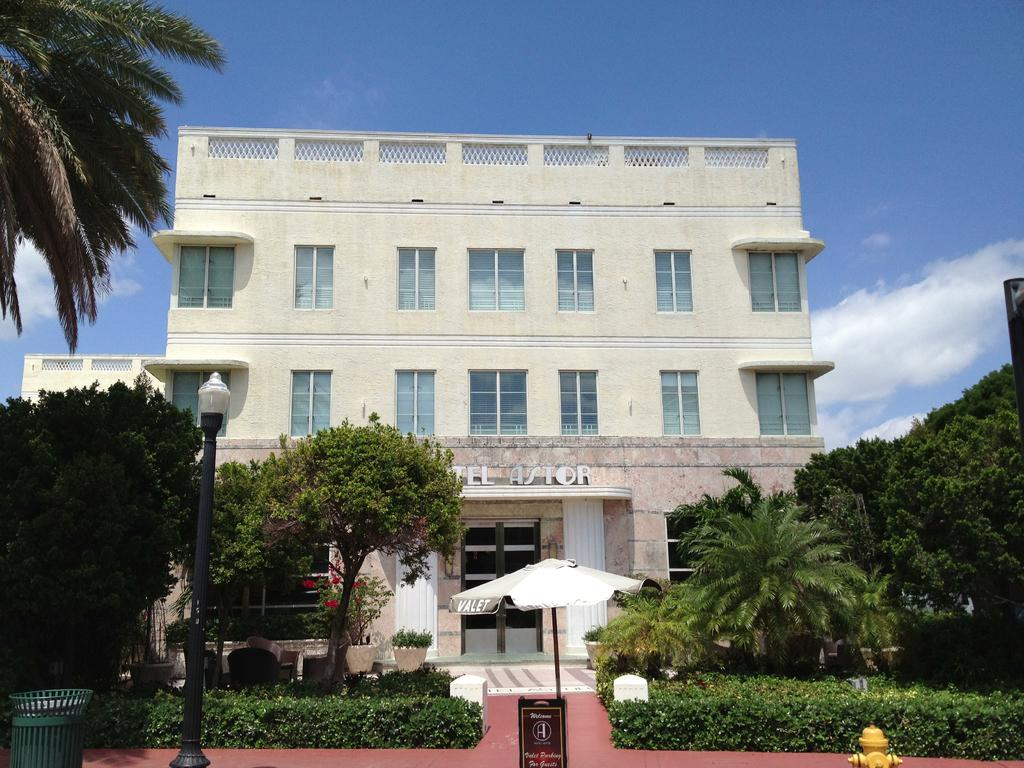<image>
Create a compact narrative representing the image presented. A large Astor brand building with a lot of foliage in front of it. 